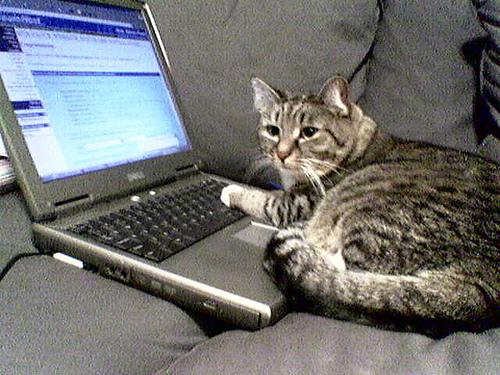Does the cat have its tail on the computer?
Give a very brief answer. Yes. Is this a natural activity for the animal in the picture?
Give a very brief answer. No. Is the cat asleep?
Quick response, please. No. Is this cat warming his paws?
Be succinct. No. 